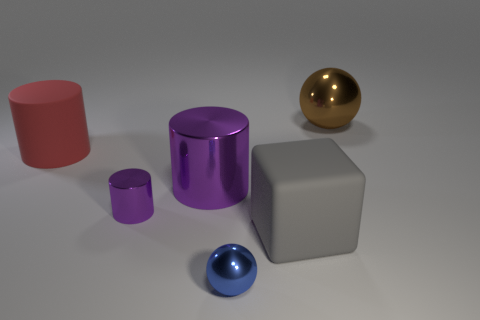There is a thing that is the same color as the large metallic cylinder; what is its shape?
Ensure brevity in your answer.  Cylinder. How many metal things have the same color as the big shiny cylinder?
Make the answer very short. 1. There is a purple object that is the same size as the gray rubber cube; what is its shape?
Provide a succinct answer. Cylinder. There is a gray cube; are there any blocks in front of it?
Ensure brevity in your answer.  No. Is the size of the brown shiny thing the same as the blue thing?
Ensure brevity in your answer.  No. There is a large matte object that is behind the gray rubber thing; what shape is it?
Ensure brevity in your answer.  Cylinder. Is there a purple metallic thing of the same size as the gray rubber cube?
Make the answer very short. Yes. There is a sphere that is the same size as the red cylinder; what is it made of?
Keep it short and to the point. Metal. There is a ball left of the gray rubber object; how big is it?
Make the answer very short. Small. What is the size of the brown ball?
Provide a short and direct response. Large. 